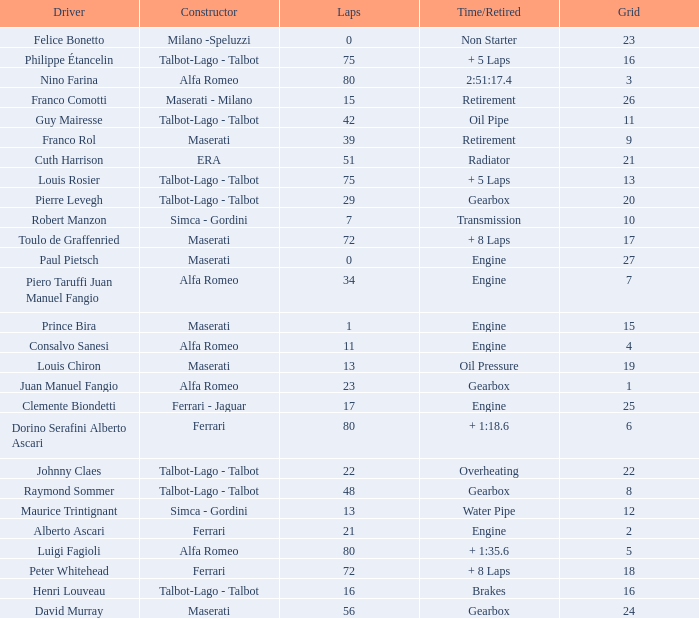What was the smallest grid for Prince bira? 15.0. 